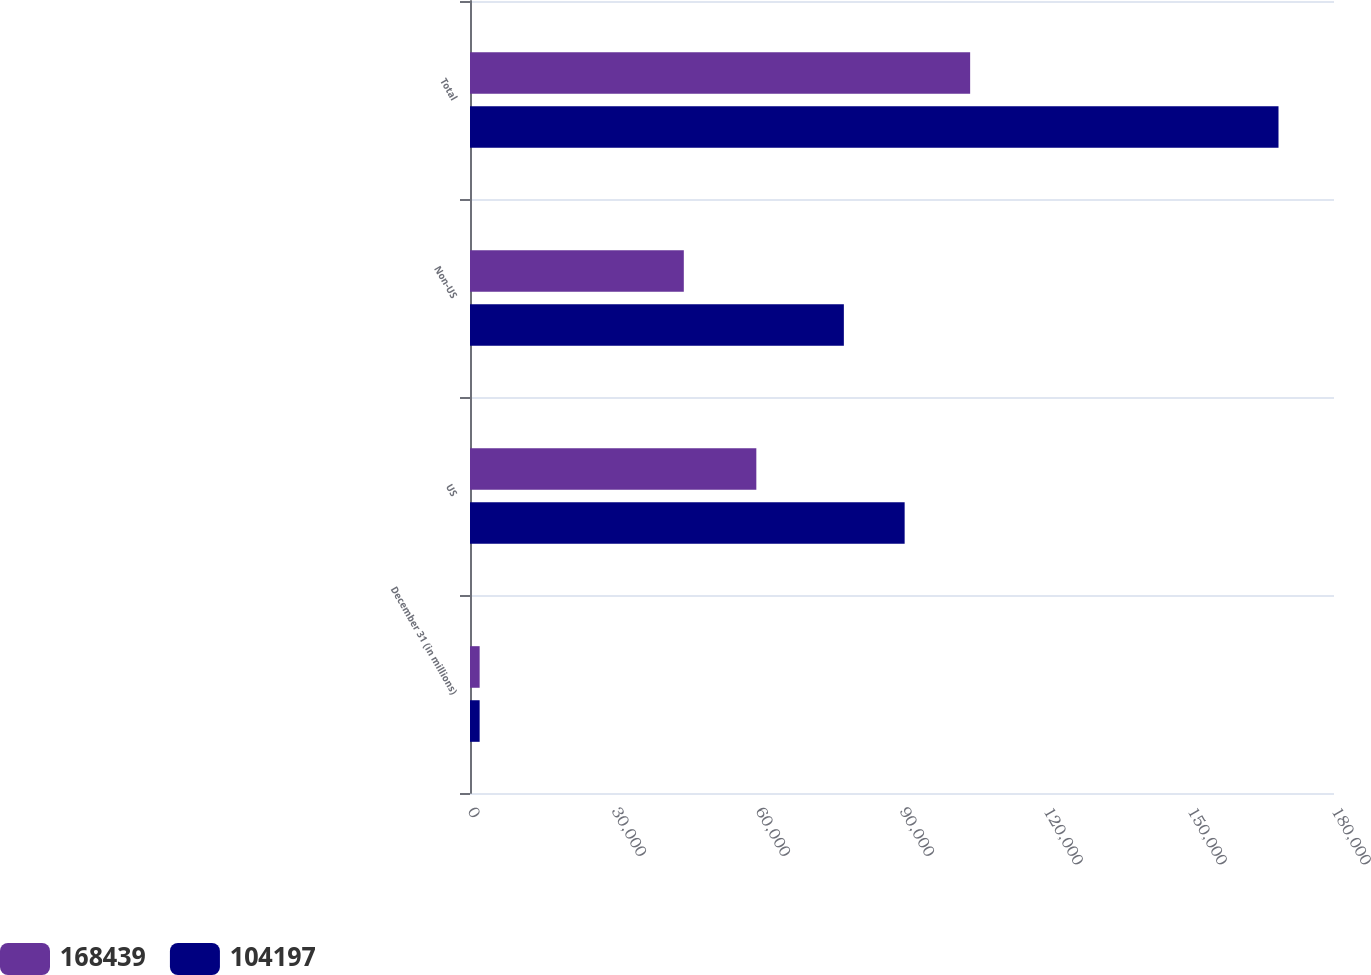Convert chart. <chart><loc_0><loc_0><loc_500><loc_500><stacked_bar_chart><ecel><fcel>December 31 (in millions)<fcel>US<fcel>Non-US<fcel>Total<nl><fcel>168439<fcel>2010<fcel>59653<fcel>44544<fcel>104197<nl><fcel>104197<fcel>2009<fcel>90552<fcel>77887<fcel>168439<nl></chart> 